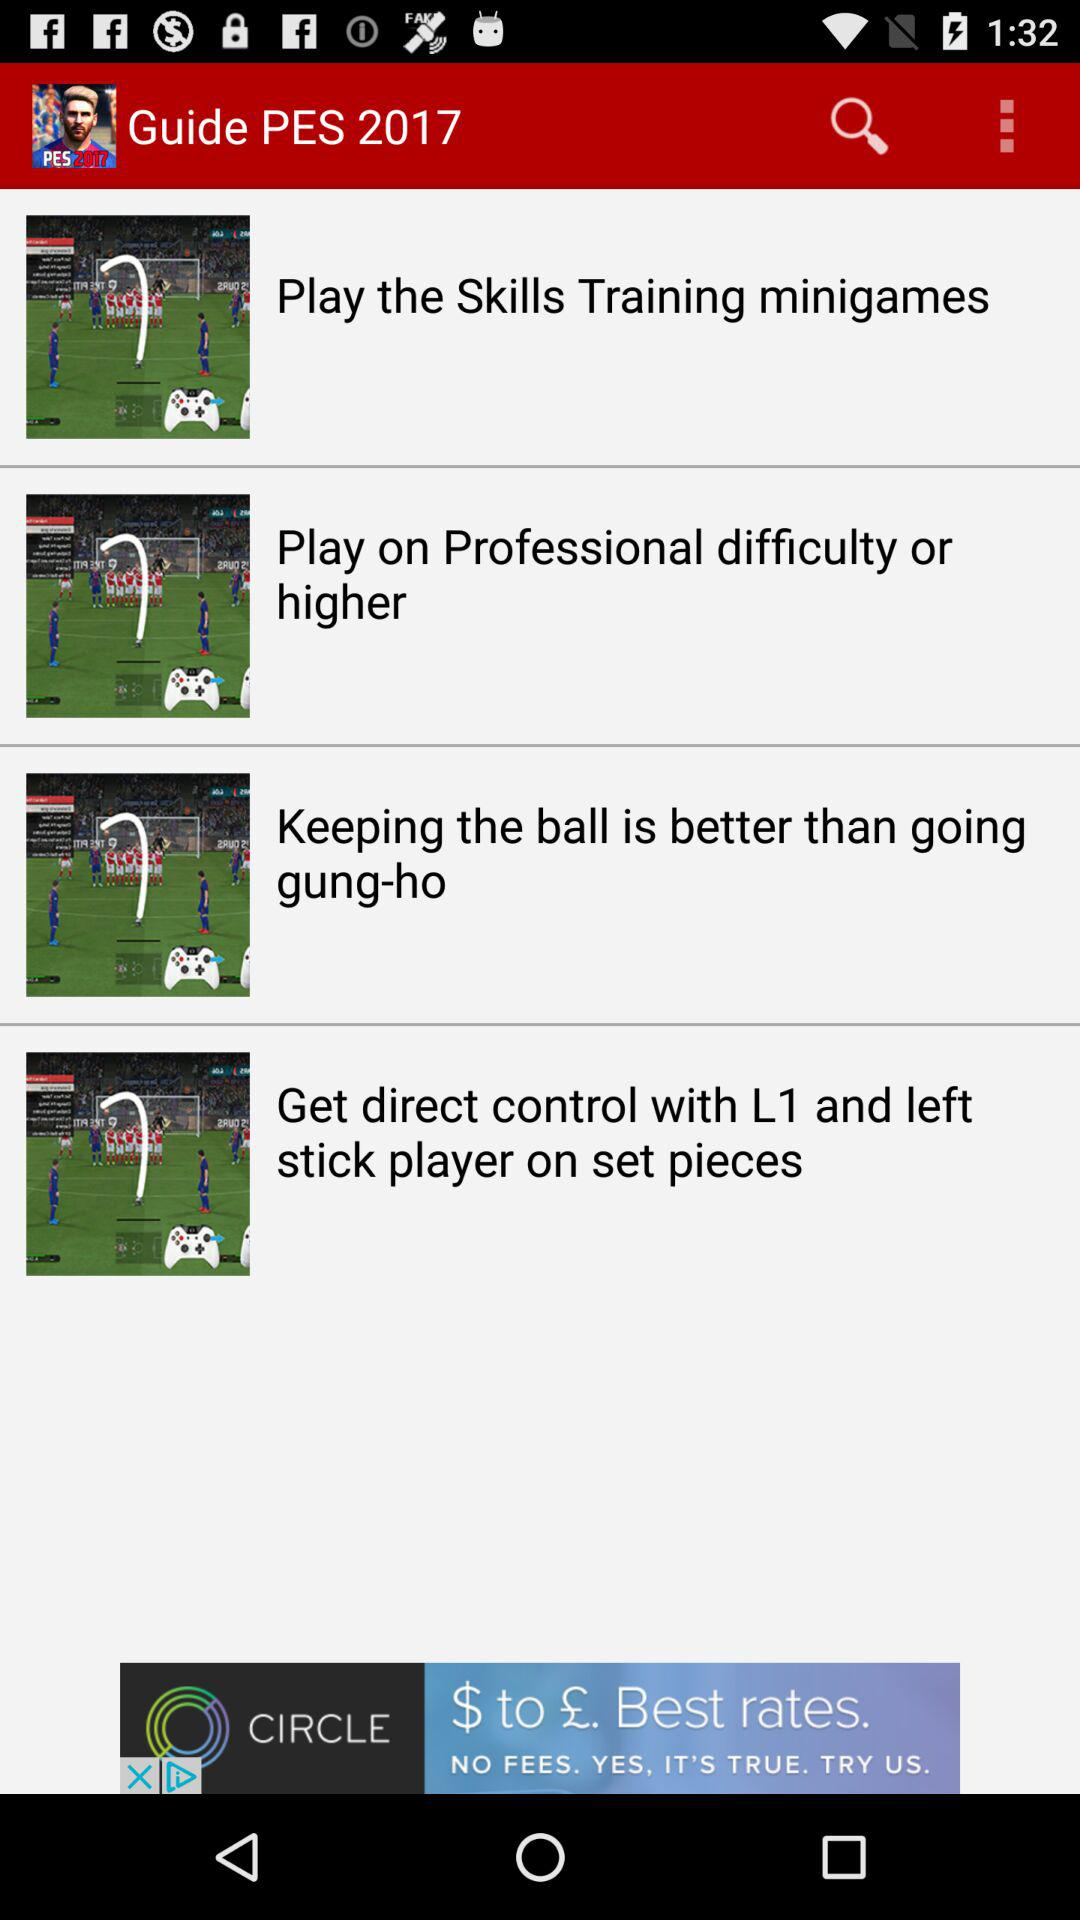How many tips are there?
Answer the question using a single word or phrase. 4 